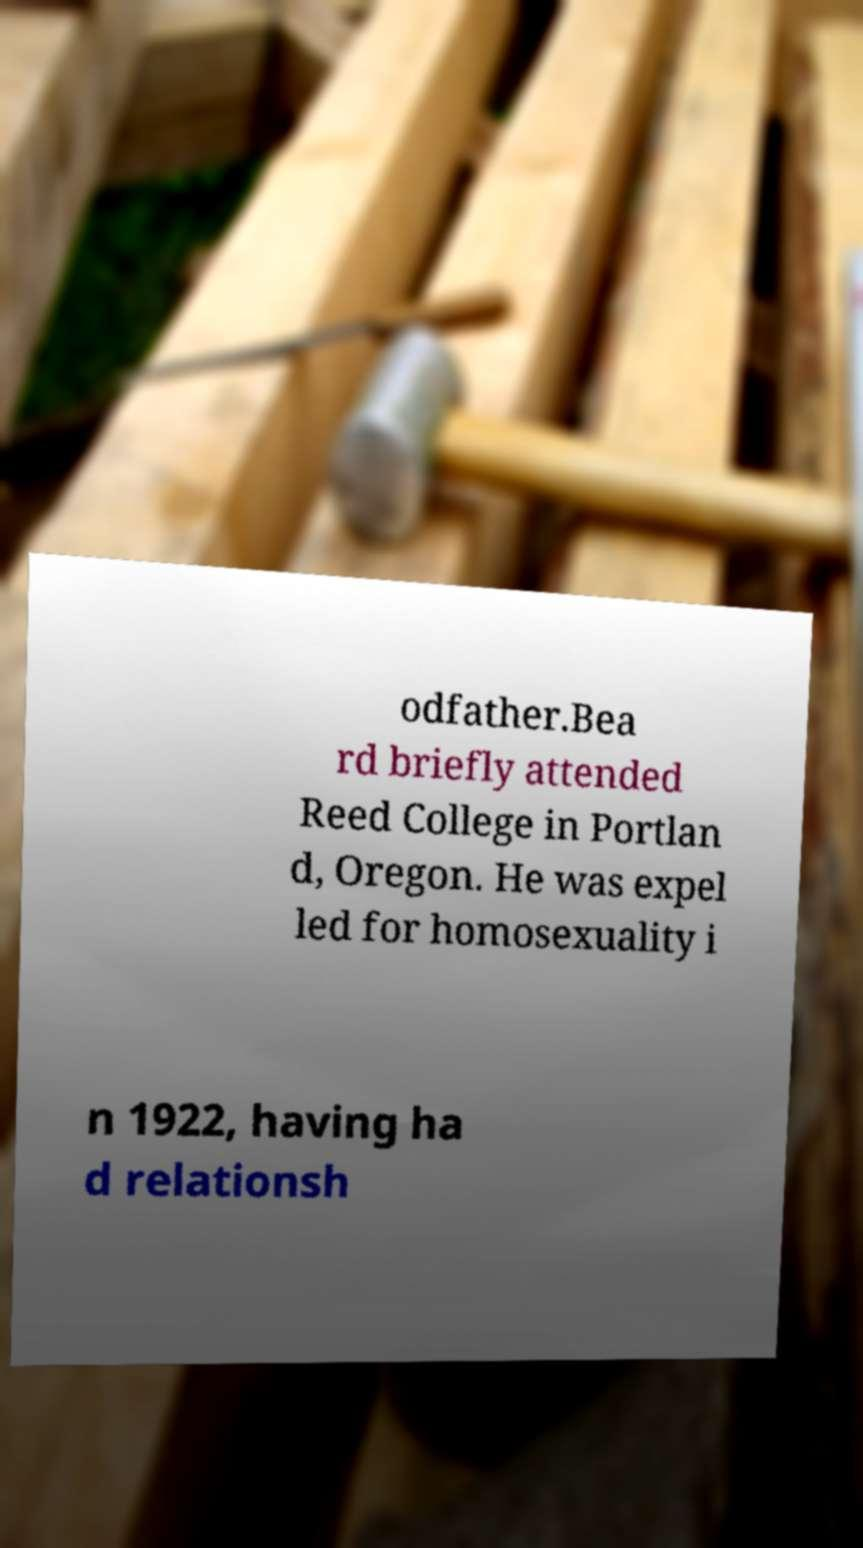Could you assist in decoding the text presented in this image and type it out clearly? odfather.Bea rd briefly attended Reed College in Portlan d, Oregon. He was expel led for homosexuality i n 1922, having ha d relationsh 